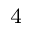<formula> <loc_0><loc_0><loc_500><loc_500>^ { 4 }</formula> 